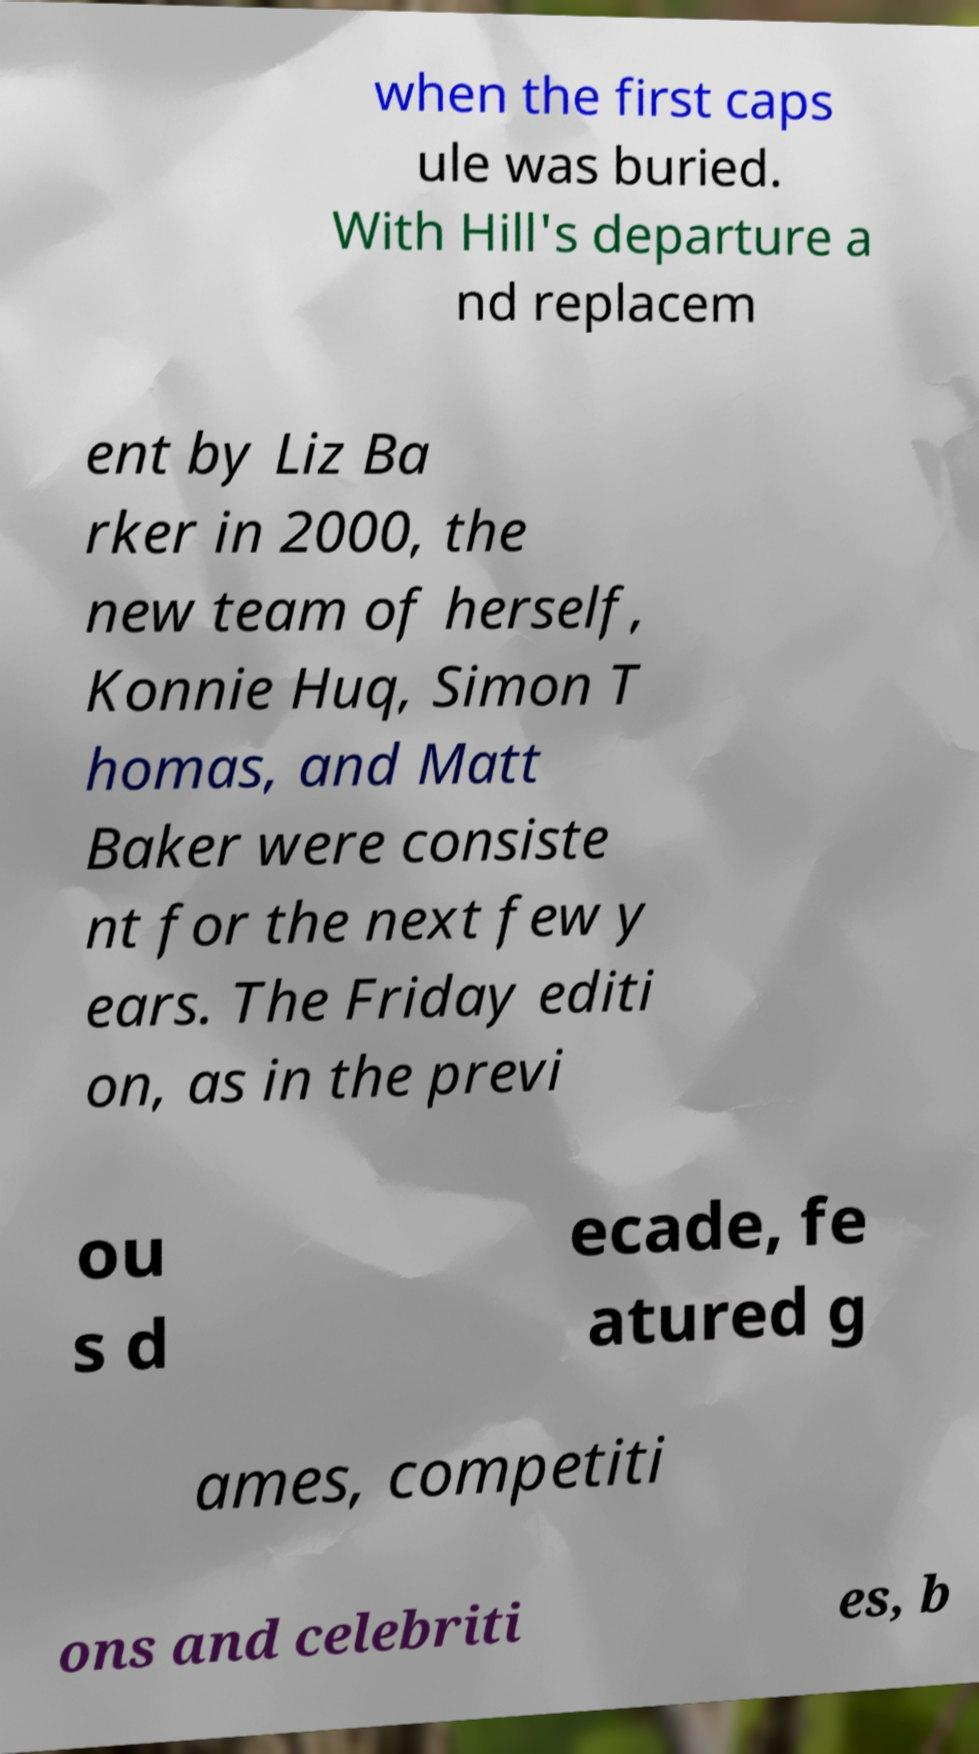For documentation purposes, I need the text within this image transcribed. Could you provide that? when the first caps ule was buried. With Hill's departure a nd replacem ent by Liz Ba rker in 2000, the new team of herself, Konnie Huq, Simon T homas, and Matt Baker were consiste nt for the next few y ears. The Friday editi on, as in the previ ou s d ecade, fe atured g ames, competiti ons and celebriti es, b 